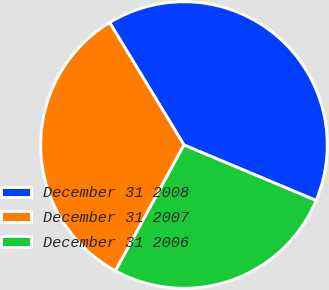Convert chart to OTSL. <chart><loc_0><loc_0><loc_500><loc_500><pie_chart><fcel>December 31 2008<fcel>December 31 2007<fcel>December 31 2006<nl><fcel>40.01%<fcel>33.38%<fcel>26.61%<nl></chart> 